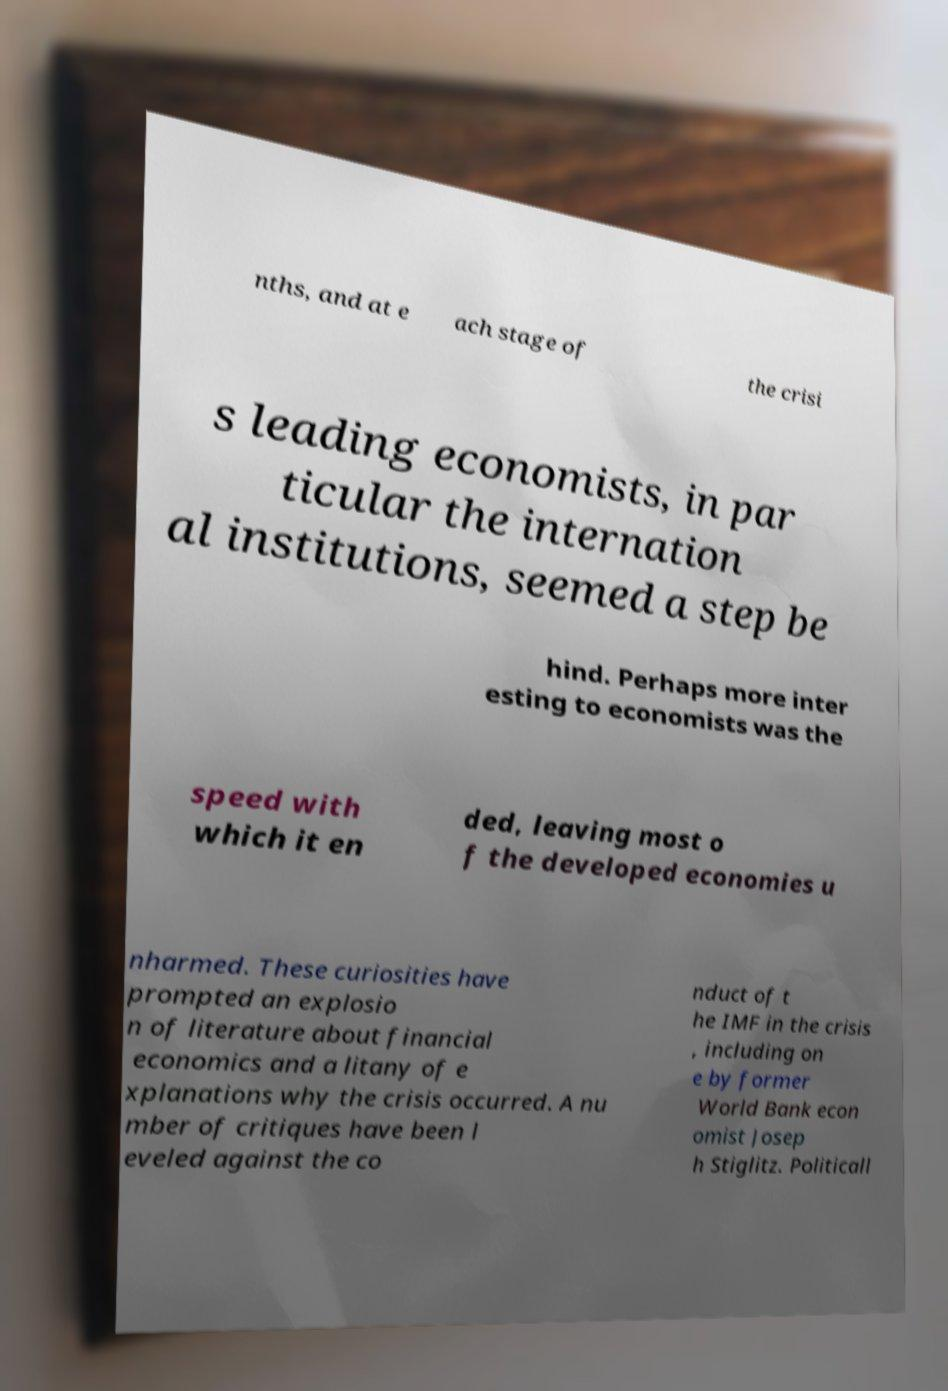What messages or text are displayed in this image? I need them in a readable, typed format. nths, and at e ach stage of the crisi s leading economists, in par ticular the internation al institutions, seemed a step be hind. Perhaps more inter esting to economists was the speed with which it en ded, leaving most o f the developed economies u nharmed. These curiosities have prompted an explosio n of literature about financial economics and a litany of e xplanations why the crisis occurred. A nu mber of critiques have been l eveled against the co nduct of t he IMF in the crisis , including on e by former World Bank econ omist Josep h Stiglitz. Politicall 